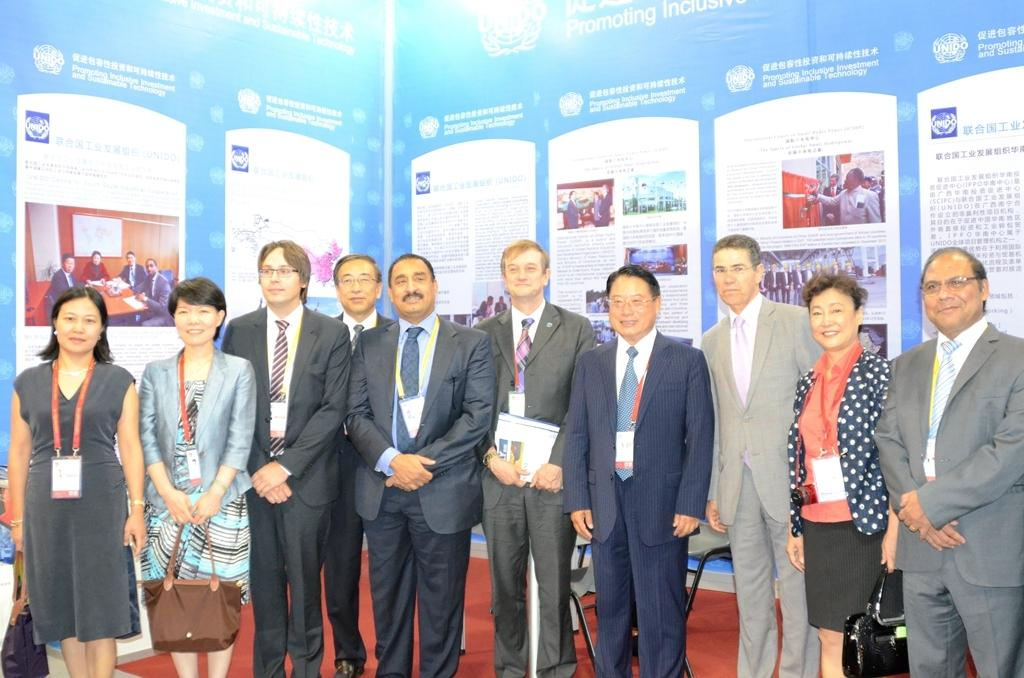What is happening in the image? There are people standing in the image. Can you describe the appearance of the people? The people are wearing different color dresses. What are two of the people holding? Two people are holding bags. What can be seen in the background of the image? There is a banner visible in the background. What is written on the banner? There is text written on the banner. How many firemen are present at the feast in the image? There is no feast or firemen present in the image. What type of stem can be seen growing from the dress of one of the people in the image? There is no stem visible on any of the people's dresses in the image. 